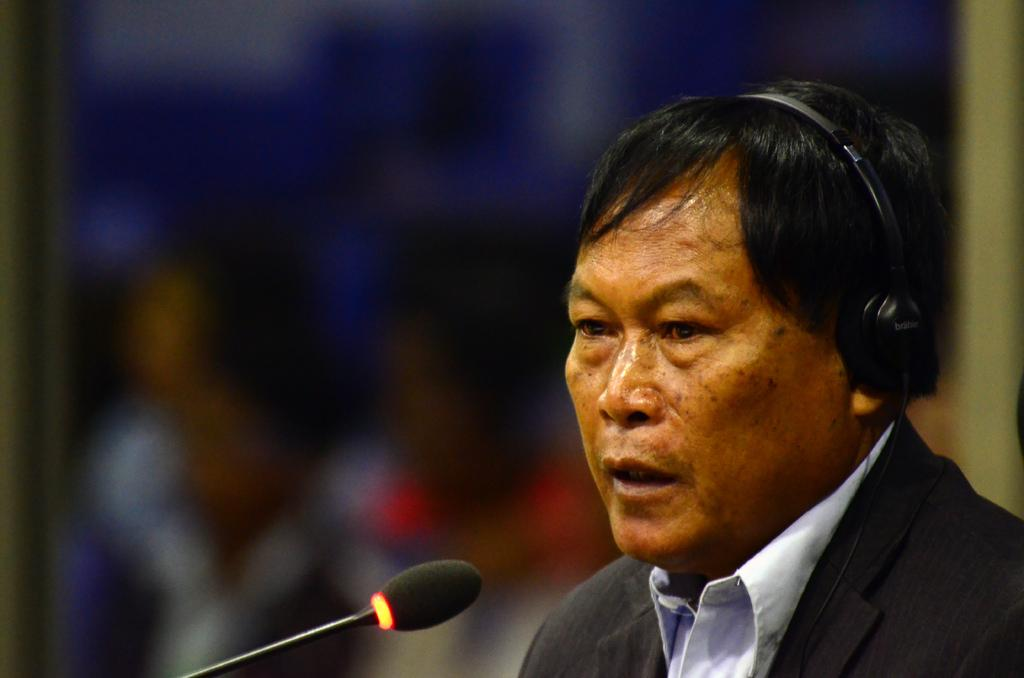Who is present in the image? There is a man in the image. What is the man wearing on his head? The man is wearing a headset. What object is placed in front of the man? There is a microphone (mic) placed in front of the man. What type of toy can be seen on the plate in the image? There is no plate or toy present in the image. 